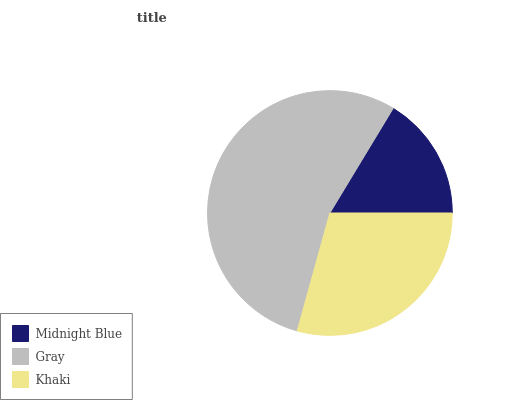Is Midnight Blue the minimum?
Answer yes or no. Yes. Is Gray the maximum?
Answer yes or no. Yes. Is Khaki the minimum?
Answer yes or no. No. Is Khaki the maximum?
Answer yes or no. No. Is Gray greater than Khaki?
Answer yes or no. Yes. Is Khaki less than Gray?
Answer yes or no. Yes. Is Khaki greater than Gray?
Answer yes or no. No. Is Gray less than Khaki?
Answer yes or no. No. Is Khaki the high median?
Answer yes or no. Yes. Is Khaki the low median?
Answer yes or no. Yes. Is Gray the high median?
Answer yes or no. No. Is Gray the low median?
Answer yes or no. No. 